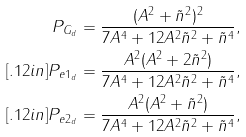Convert formula to latex. <formula><loc_0><loc_0><loc_500><loc_500>P _ { G _ { d } } & = \frac { ( A ^ { 2 } + \tilde { n } ^ { 2 } ) ^ { 2 } } { 7 A ^ { 4 } + 1 2 A ^ { 2 } \tilde { n } ^ { 2 } + \tilde { n } ^ { 4 } } , \\ [ . 1 2 i n ] P _ { e 1 _ { d } } & = \frac { A ^ { 2 } ( A ^ { 2 } + 2 \tilde { n } ^ { 2 } ) } { 7 A ^ { 4 } + 1 2 A ^ { 2 } \tilde { n } ^ { 2 } + \tilde { n } ^ { 4 } } , \\ [ . 1 2 i n ] P _ { e 2 _ { d } } & = \frac { A ^ { 2 } ( A ^ { 2 } + \tilde { n } ^ { 2 } ) } { 7 A ^ { 4 } + 1 2 A ^ { 2 } \tilde { n } ^ { 2 } + \tilde { n } ^ { 4 } } ,</formula> 